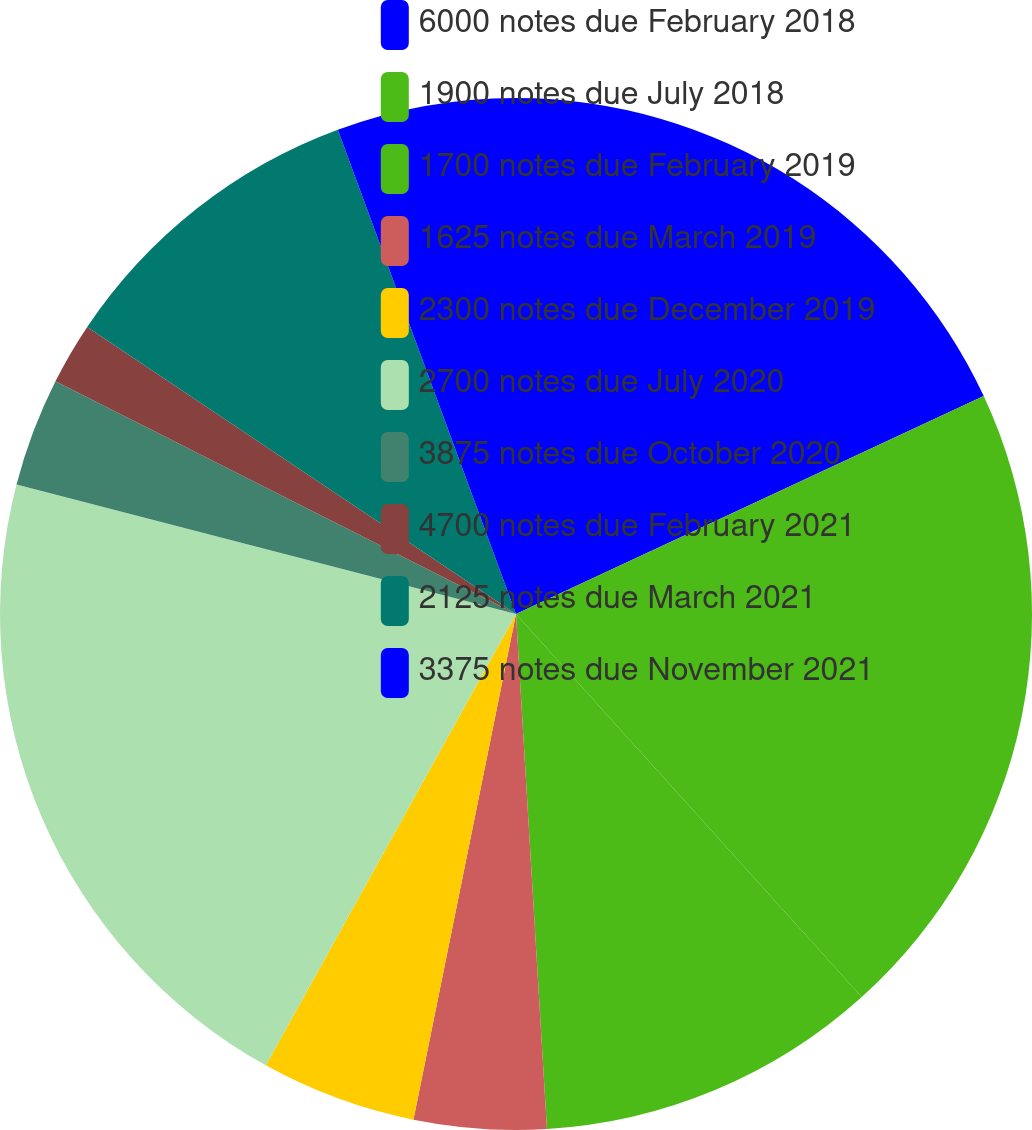Convert chart to OTSL. <chart><loc_0><loc_0><loc_500><loc_500><pie_chart><fcel>6000 notes due February 2018<fcel>1900 notes due July 2018<fcel>1700 notes due February 2019<fcel>1625 notes due March 2019<fcel>2300 notes due December 2019<fcel>2700 notes due July 2020<fcel>3875 notes due October 2020<fcel>4700 notes due February 2021<fcel>2125 notes due March 2021<fcel>3375 notes due November 2021<nl><fcel>18.06%<fcel>20.25%<fcel>10.73%<fcel>4.14%<fcel>4.87%<fcel>20.98%<fcel>3.41%<fcel>1.94%<fcel>10.0%<fcel>5.61%<nl></chart> 